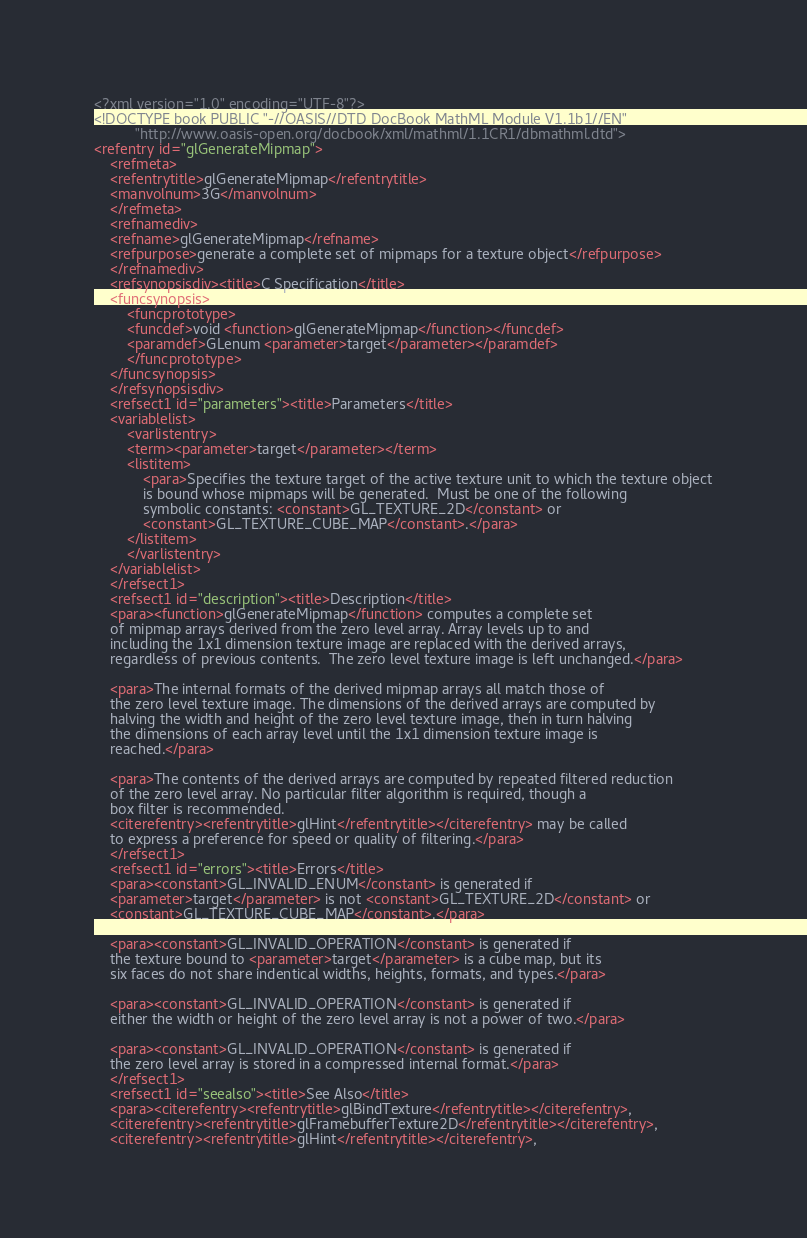<code> <loc_0><loc_0><loc_500><loc_500><_XML_><?xml version="1.0" encoding="UTF-8"?>
<!DOCTYPE book PUBLIC "-//OASIS//DTD DocBook MathML Module V1.1b1//EN"
	      "http://www.oasis-open.org/docbook/xml/mathml/1.1CR1/dbmathml.dtd">
<refentry id="glGenerateMipmap">
    <refmeta>
	<refentrytitle>glGenerateMipmap</refentrytitle>
	<manvolnum>3G</manvolnum>
    </refmeta>
    <refnamediv>
	<refname>glGenerateMipmap</refname>
	<refpurpose>generate a complete set of mipmaps for a texture object</refpurpose>
    </refnamediv>
    <refsynopsisdiv><title>C Specification</title>
	<funcsynopsis>
	    <funcprototype>
		<funcdef>void <function>glGenerateMipmap</function></funcdef>
		<paramdef>GLenum <parameter>target</parameter></paramdef>
	    </funcprototype>
	</funcsynopsis>
    </refsynopsisdiv>
    <refsect1 id="parameters"><title>Parameters</title>
	<variablelist>
	    <varlistentry>
		<term><parameter>target</parameter></term>
		<listitem>
		    <para>Specifies the texture target of the active texture unit to which the texture object
		    is bound whose mipmaps will be generated.  Must be one of the following
		    symbolic constants: <constant>GL_TEXTURE_2D</constant> or
		    <constant>GL_TEXTURE_CUBE_MAP</constant>.</para>
		</listitem>
	    </varlistentry>
	</variablelist>
    </refsect1>
    <refsect1 id="description"><title>Description</title>
	<para><function>glGenerateMipmap</function> computes a complete set
	of mipmap arrays derived from the zero level array. Array levels up to and
	including the 1x1 dimension texture image are replaced with the derived arrays,
	regardless of previous contents.  The zero level texture image is left unchanged.</para>

	<para>The internal formats of the derived mipmap arrays all match those of
	the zero level texture image. The dimensions of the derived arrays are computed by
	halving the width and height of the zero level texture image, then in turn halving
	the dimensions of each array level until the 1x1 dimension texture image is 
	reached.</para>
	
	<para>The contents of the derived arrays are computed by repeated filtered reduction
	of the zero level array. No particular filter algorithm is required, though a
	box filter is recommended. 
	<citerefentry><refentrytitle>glHint</refentrytitle></citerefentry> may be called
	to express a preference for speed or quality of filtering.</para>
    </refsect1>
    <refsect1 id="errors"><title>Errors</title>
	<para><constant>GL_INVALID_ENUM</constant> is generated if
	<parameter>target</parameter> is not <constant>GL_TEXTURE_2D</constant> or
	<constant>GL_TEXTURE_CUBE_MAP</constant>.</para>

	<para><constant>GL_INVALID_OPERATION</constant> is generated if
	the texture bound to <parameter>target</parameter> is a cube map, but its
	six faces do not share indentical widths, heights, formats, and types.</para>

	<para><constant>GL_INVALID_OPERATION</constant> is generated if
	either the width or height of the zero level array is not a power of two.</para>

	<para><constant>GL_INVALID_OPERATION</constant> is generated if
	the zero level array is stored in a compressed internal format.</para>
    </refsect1>
    <refsect1 id="seealso"><title>See Also</title>
	<para><citerefentry><refentrytitle>glBindTexture</refentrytitle></citerefentry>,
	<citerefentry><refentrytitle>glFramebufferTexture2D</refentrytitle></citerefentry>,
	<citerefentry><refentrytitle>glHint</refentrytitle></citerefentry>,</code> 